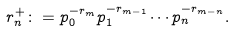<formula> <loc_0><loc_0><loc_500><loc_500>r ^ { + } _ { n } \colon = p _ { 0 } ^ { - r _ { m } } p _ { 1 } ^ { - r _ { m - 1 } } \cdots p _ { n } ^ { - r _ { m - n } } .</formula> 